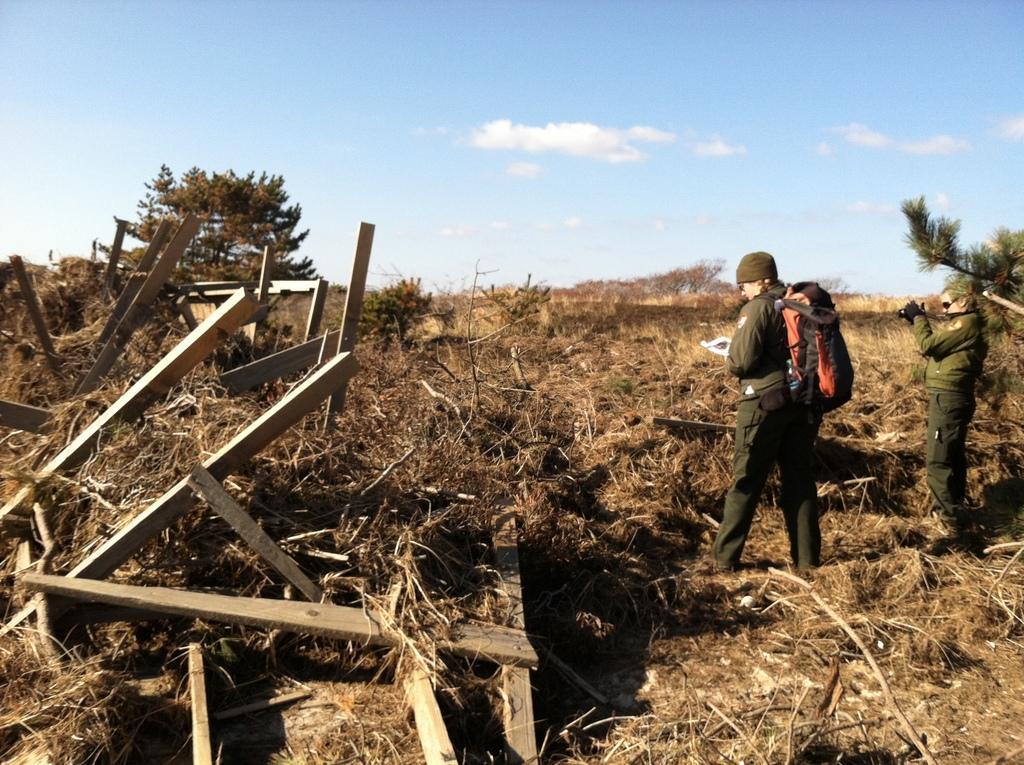Please provide a concise description of this image. There are two people standing. This person is holding a camera. I can see the kind of wooden poles. This looks like the dried grass. These are the trees. I can see the clouds in the sky. 